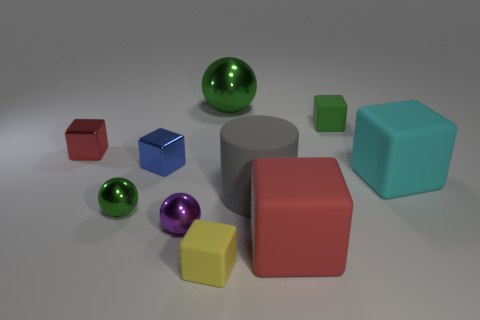What number of purple objects have the same size as the yellow block?
Provide a succinct answer. 1. Is the number of small gray rubber things less than the number of large things?
Ensure brevity in your answer.  Yes. There is a tiny object that is right of the matte thing that is to the left of the large green metallic sphere; what is its shape?
Your answer should be compact. Cube. What shape is the blue shiny object that is the same size as the yellow cube?
Your answer should be very brief. Cube. Are there any other red things of the same shape as the red metal object?
Your answer should be very brief. Yes. What material is the large red cube?
Ensure brevity in your answer.  Rubber. There is a tiny green ball; are there any cyan blocks behind it?
Your answer should be very brief. Yes. There is a large rubber block that is behind the purple metal object; how many big gray rubber cylinders are behind it?
Ensure brevity in your answer.  0. There is a cyan thing that is the same size as the gray thing; what material is it?
Offer a terse response. Rubber. How many other objects are there of the same material as the small blue object?
Offer a very short reply. 4. 